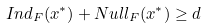<formula> <loc_0><loc_0><loc_500><loc_500>I n d _ { F } ( x ^ { \ast } ) + N u l l _ { F } ( x ^ { \ast } ) \geq d</formula> 